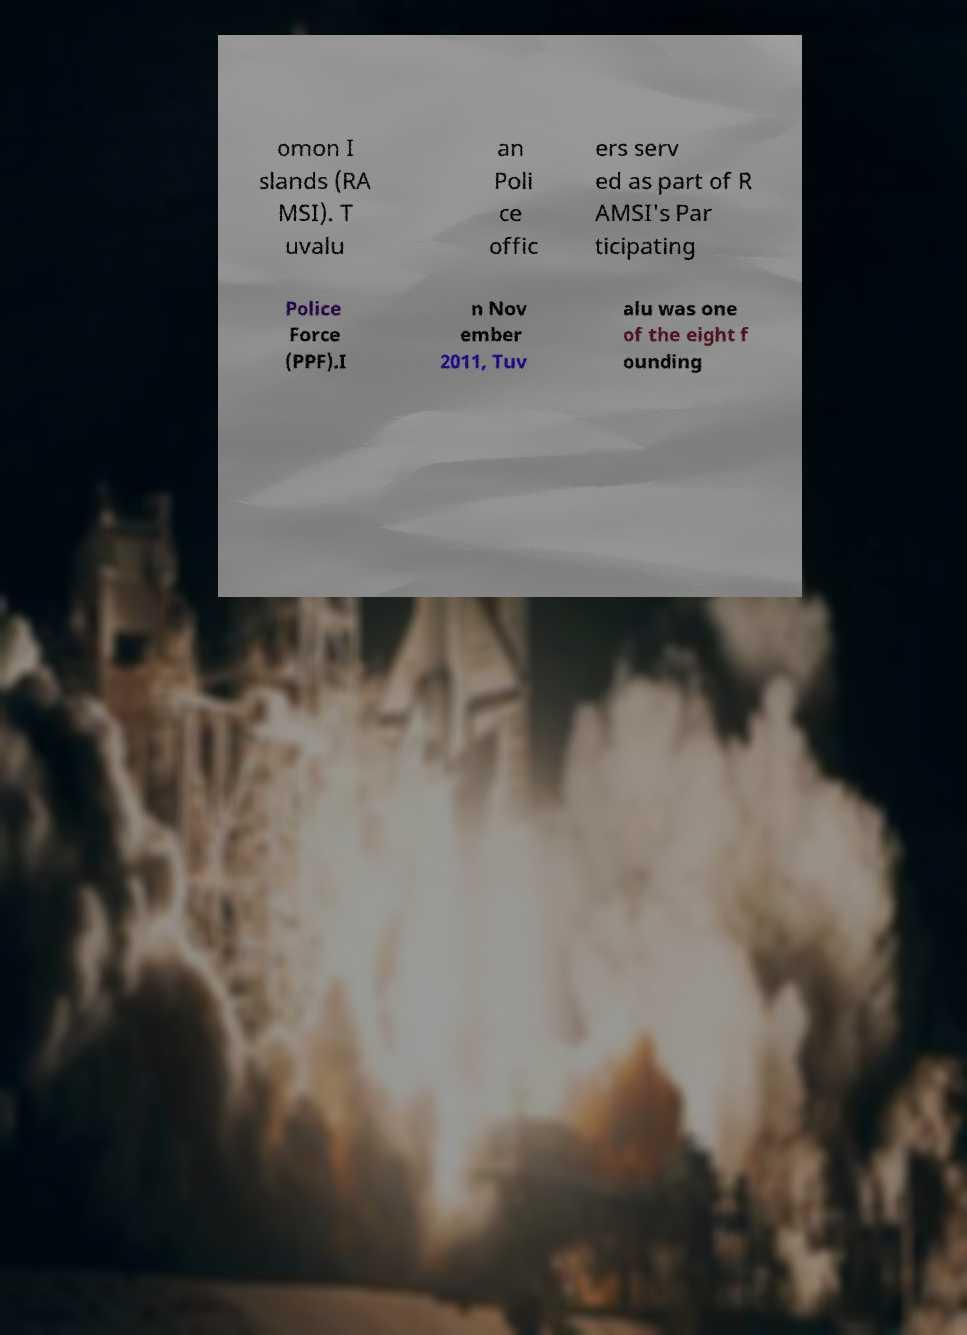Can you accurately transcribe the text from the provided image for me? omon I slands (RA MSI). T uvalu an Poli ce offic ers serv ed as part of R AMSI's Par ticipating Police Force (PPF).I n Nov ember 2011, Tuv alu was one of the eight f ounding 